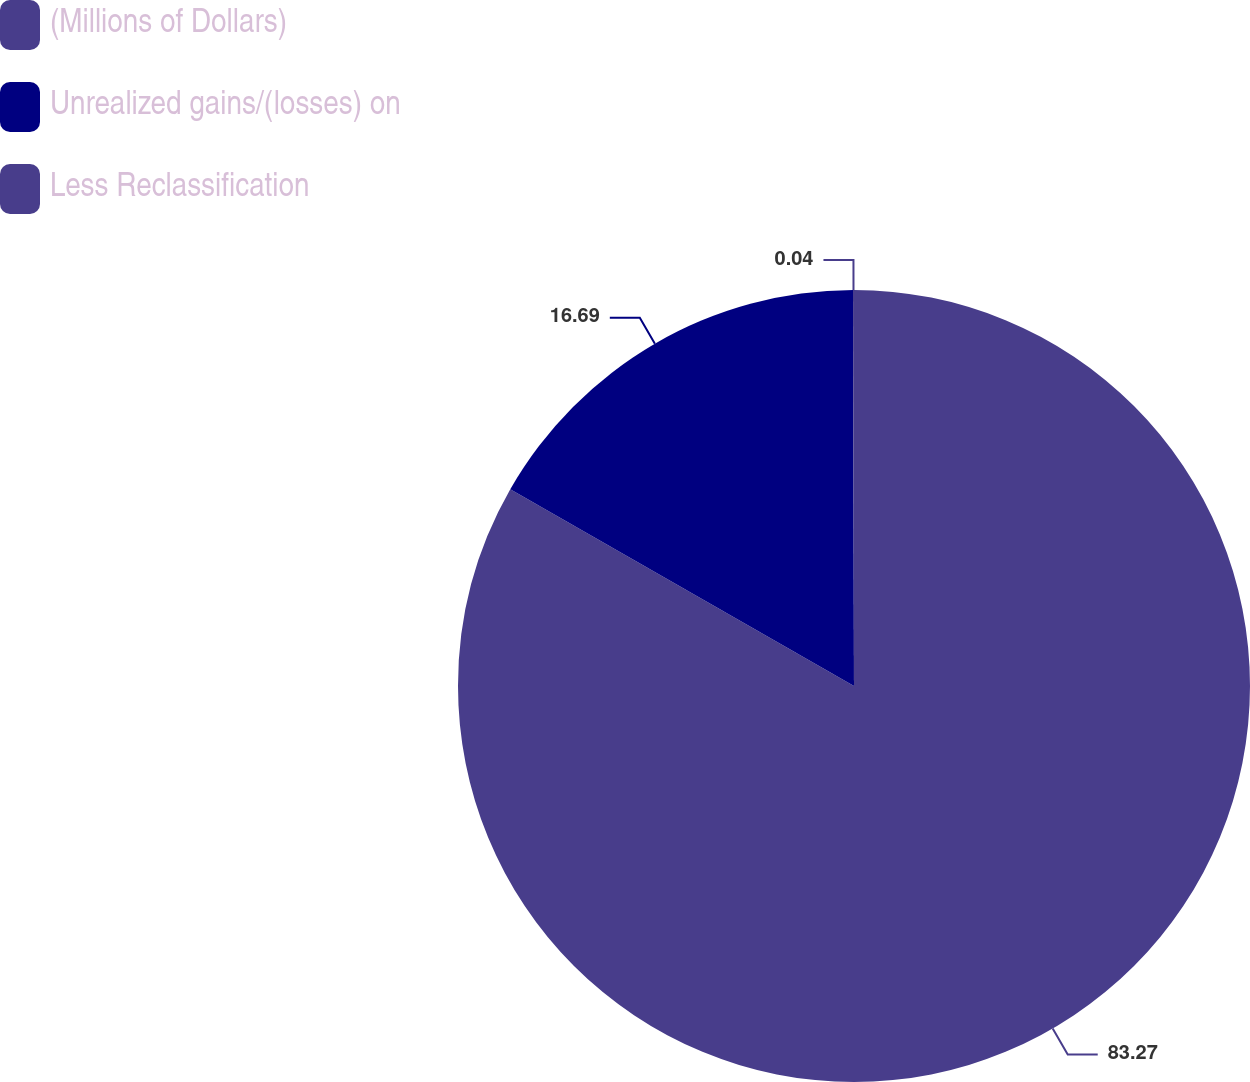Convert chart. <chart><loc_0><loc_0><loc_500><loc_500><pie_chart><fcel>(Millions of Dollars)<fcel>Unrealized gains/(losses) on<fcel>Less Reclassification<nl><fcel>83.27%<fcel>16.69%<fcel>0.04%<nl></chart> 